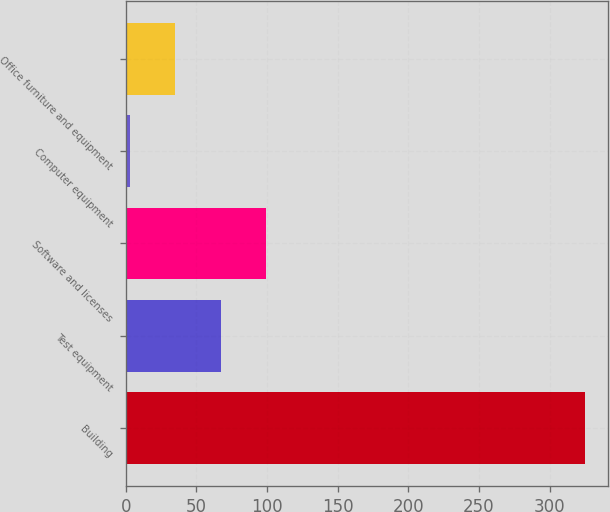Convert chart to OTSL. <chart><loc_0><loc_0><loc_500><loc_500><bar_chart><fcel>Building<fcel>Test equipment<fcel>Software and licenses<fcel>Computer equipment<fcel>Office furniture and equipment<nl><fcel>325<fcel>67.4<fcel>99.6<fcel>3<fcel>35.2<nl></chart> 